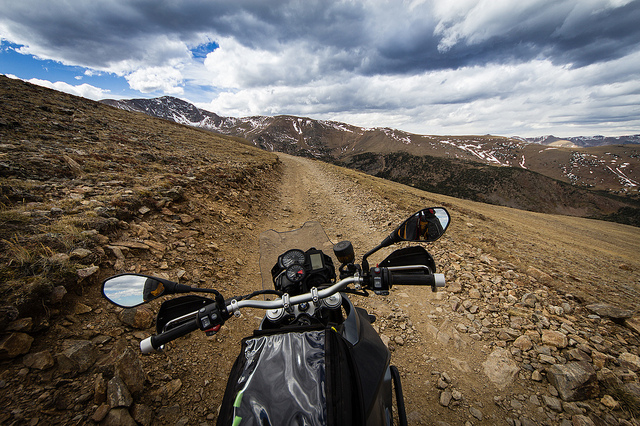Are those mountains in the distance? Yes, the distant horizon is punctuated by a range of mountains, some of their peaks still capped with snow. 